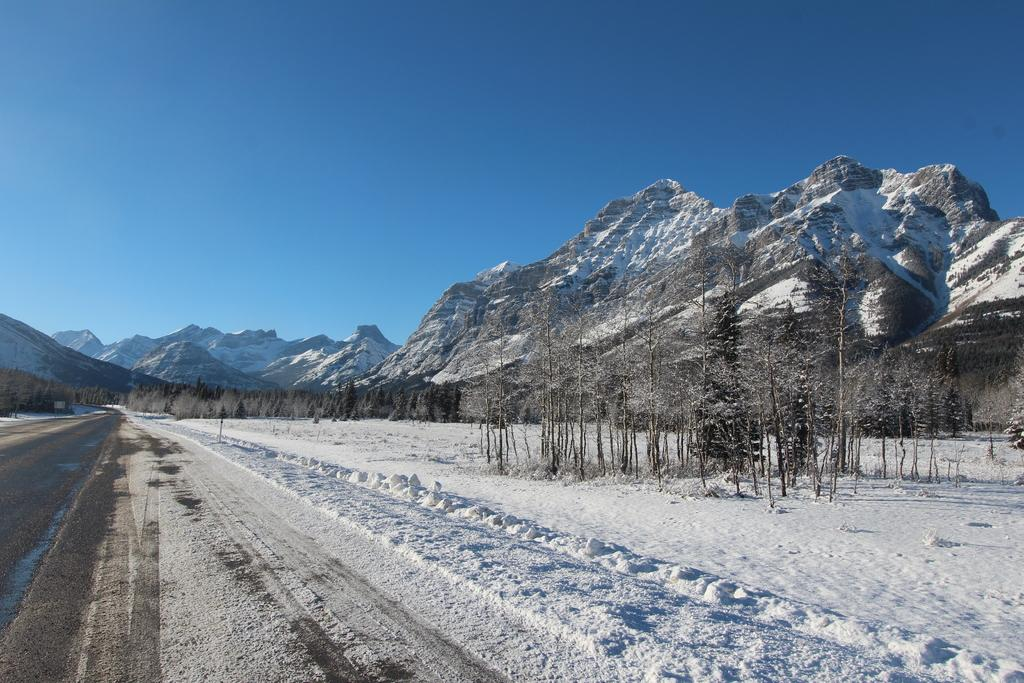What is located at the bottom of the image? There is a walkway at the bottom of the image. What is covering the walkway at the bottom of the image? There is snow at the bottom of the image. What type of natural vegetation can be seen in the image? There are trees visible in the image. What type of geographical feature is visible in the background of the image? There are mountains in the image. What is visible at the top of the image? The sky is visible at the top of the image. What type of stone is being used to build the basket in the image? There is no basket or stone present in the image. How does the breath of the trees affect the snow at the bottom of the image? Trees do not have breath, and there is no interaction between the trees and the snow in the image. 